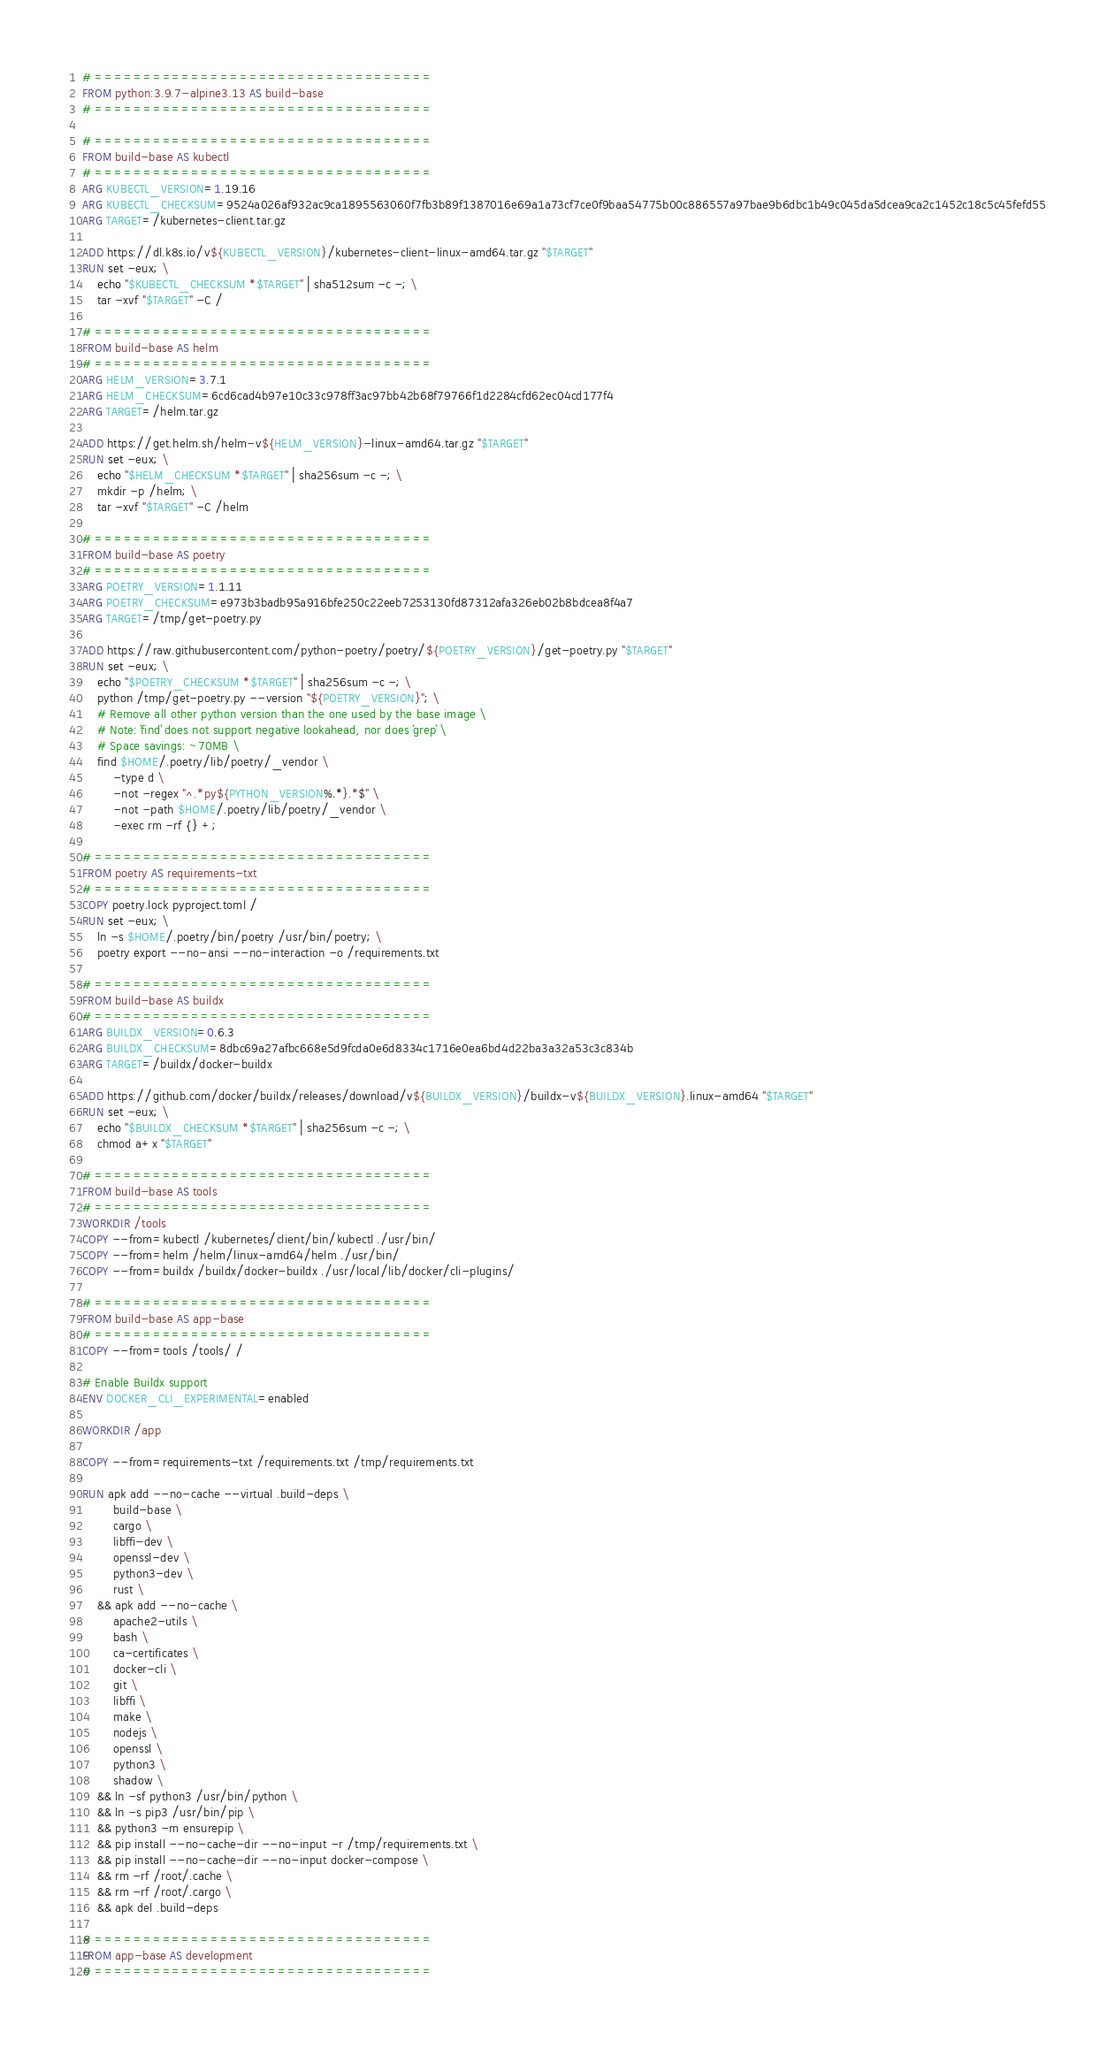<code> <loc_0><loc_0><loc_500><loc_500><_Dockerfile_># ===================================
FROM python:3.9.7-alpine3.13 AS build-base
# ===================================

# ===================================
FROM build-base AS kubectl
# ===================================
ARG KUBECTL_VERSION=1.19.16
ARG KUBECTL_CHECKSUM=9524a026af932ac9ca1895563060f7fb3b89f1387016e69a1a73cf7ce0f9baa54775b00c886557a97bae9b6dbc1b49c045da5dcea9ca2c1452c18c5c45fefd55
ARG TARGET=/kubernetes-client.tar.gz

ADD https://dl.k8s.io/v${KUBECTL_VERSION}/kubernetes-client-linux-amd64.tar.gz "$TARGET"
RUN set -eux; \
    echo "$KUBECTL_CHECKSUM *$TARGET" | sha512sum -c -; \
    tar -xvf "$TARGET" -C /

# ===================================
FROM build-base AS helm
# ===================================
ARG HELM_VERSION=3.7.1
ARG HELM_CHECKSUM=6cd6cad4b97e10c33c978ff3ac97bb42b68f79766f1d2284cfd62ec04cd177f4
ARG TARGET=/helm.tar.gz

ADD https://get.helm.sh/helm-v${HELM_VERSION}-linux-amd64.tar.gz "$TARGET"
RUN set -eux; \
    echo "$HELM_CHECKSUM *$TARGET" | sha256sum -c -; \
    mkdir -p /helm; \
    tar -xvf "$TARGET" -C /helm

# ===================================
FROM build-base AS poetry
# ===================================
ARG POETRY_VERSION=1.1.11
ARG POETRY_CHECKSUM=e973b3badb95a916bfe250c22eeb7253130fd87312afa326eb02b8bdcea8f4a7
ARG TARGET=/tmp/get-poetry.py

ADD https://raw.githubusercontent.com/python-poetry/poetry/${POETRY_VERSION}/get-poetry.py "$TARGET"
RUN set -eux; \
    echo "$POETRY_CHECKSUM *$TARGET" | sha256sum -c -; \
    python /tmp/get-poetry.py --version "${POETRY_VERSION}"; \
    # Remove all other python version than the one used by the base image \
    # Note: `find` does not support negative lookahead, nor does `grep` \
    # Space savings: ~70MB \
    find $HOME/.poetry/lib/poetry/_vendor \
        -type d \
        -not -regex "^.*py${PYTHON_VERSION%.*}.*$" \
        -not -path $HOME/.poetry/lib/poetry/_vendor \
        -exec rm -rf {} +;

# ===================================
FROM poetry AS requirements-txt
# ===================================
COPY poetry.lock pyproject.toml /
RUN set -eux; \
    ln -s $HOME/.poetry/bin/poetry /usr/bin/poetry; \
    poetry export --no-ansi --no-interaction -o /requirements.txt

# ===================================
FROM build-base AS buildx
# ===================================
ARG BUILDX_VERSION=0.6.3
ARG BUILDX_CHECKSUM=8dbc69a27afbc668e5d9fcda0e6d8334c1716e0ea6bd4d22ba3a32a53c3c834b
ARG TARGET=/buildx/docker-buildx

ADD https://github.com/docker/buildx/releases/download/v${BUILDX_VERSION}/buildx-v${BUILDX_VERSION}.linux-amd64 "$TARGET"
RUN set -eux; \
    echo "$BUILDX_CHECKSUM *$TARGET" | sha256sum -c -; \
    chmod a+x "$TARGET"

# ===================================
FROM build-base AS tools
# ===================================
WORKDIR /tools
COPY --from=kubectl /kubernetes/client/bin/kubectl ./usr/bin/
COPY --from=helm /helm/linux-amd64/helm ./usr/bin/
COPY --from=buildx /buildx/docker-buildx ./usr/local/lib/docker/cli-plugins/

# ===================================
FROM build-base AS app-base
# ===================================
COPY --from=tools /tools/ /

# Enable Buildx support
ENV DOCKER_CLI_EXPERIMENTAL=enabled

WORKDIR /app

COPY --from=requirements-txt /requirements.txt /tmp/requirements.txt

RUN apk add --no-cache --virtual .build-deps \
        build-base \
        cargo \
        libffi-dev \
        openssl-dev \
        python3-dev \
        rust \
    && apk add --no-cache \
        apache2-utils \
        bash \
        ca-certificates \
        docker-cli \
        git \
        libffi \
        make \
        nodejs \
        openssl \
        python3 \
        shadow \
    && ln -sf python3 /usr/bin/python \
    && ln -s pip3 /usr/bin/pip \
    && python3 -m ensurepip \
    && pip install --no-cache-dir --no-input -r /tmp/requirements.txt \
    && pip install --no-cache-dir --no-input docker-compose \
    && rm -rf /root/.cache \
    && rm -rf /root/.cargo \
    && apk del .build-deps

# ===================================
FROM app-base AS development
# ===================================</code> 